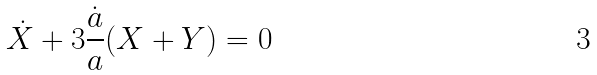<formula> <loc_0><loc_0><loc_500><loc_500>\dot { X } + 3 \frac { \dot { a } } { a } ( X + Y ) = 0</formula> 